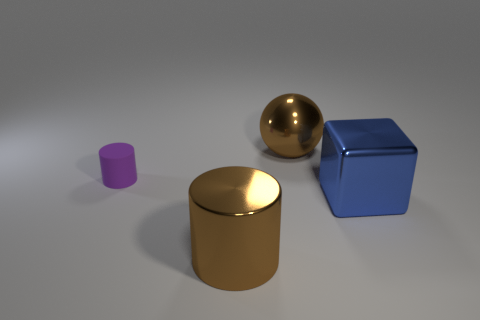Is there any other thing that has the same size as the purple cylinder?
Your answer should be compact. No. What is the cylinder behind the big block made of?
Your response must be concise. Rubber. What shape is the brown object in front of the thing behind the small matte cylinder?
Your answer should be very brief. Cylinder. There is a matte object; is its shape the same as the brown metallic object that is in front of the matte thing?
Make the answer very short. Yes. There is a brown shiny object behind the big metallic cylinder; what number of cylinders are to the right of it?
Your response must be concise. 0. There is another thing that is the same shape as the small matte thing; what material is it?
Your answer should be compact. Metal. What number of green things are large metal cubes or metal balls?
Give a very brief answer. 0. Are there any other things that are the same color as the tiny object?
Your answer should be very brief. No. There is a big metallic thing that is on the left side of the large thing that is behind the purple cylinder; what is its color?
Your answer should be very brief. Brown. Are there fewer big blue blocks to the left of the purple matte thing than rubber things in front of the big blue metallic thing?
Make the answer very short. No. 